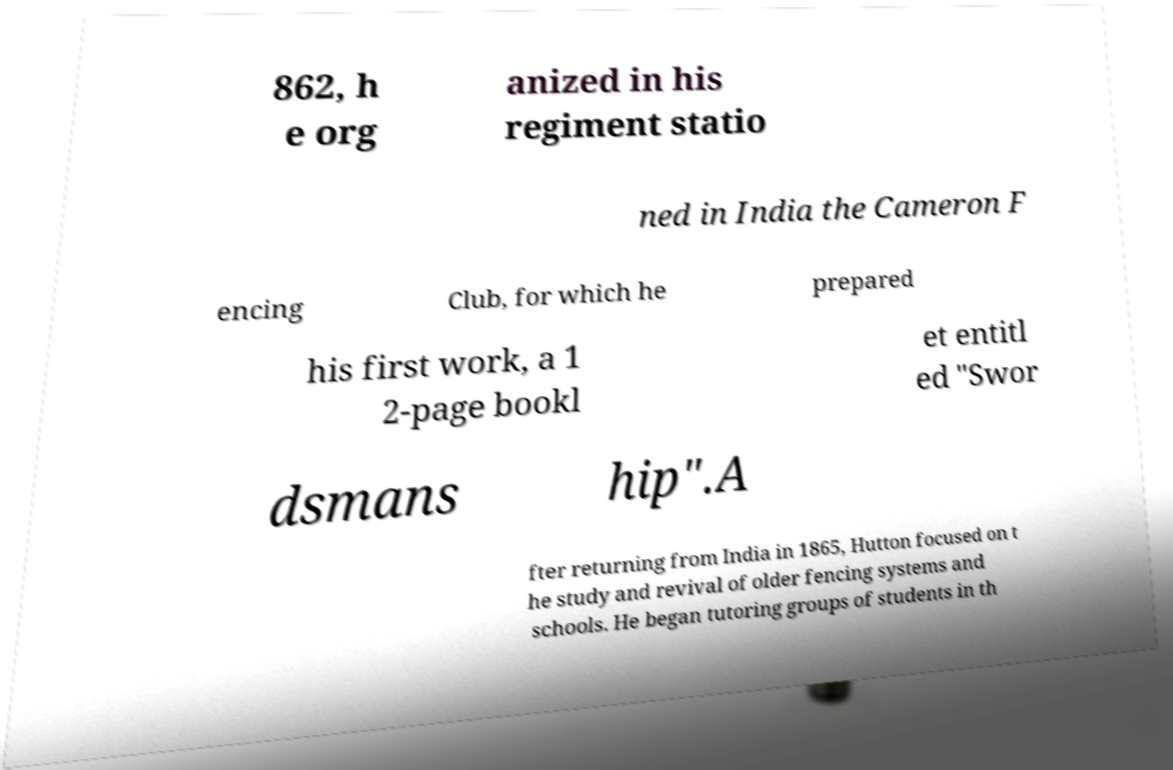Can you read and provide the text displayed in the image?This photo seems to have some interesting text. Can you extract and type it out for me? 862, h e org anized in his regiment statio ned in India the Cameron F encing Club, for which he prepared his first work, a 1 2-page bookl et entitl ed "Swor dsmans hip".A fter returning from India in 1865, Hutton focused on t he study and revival of older fencing systems and schools. He began tutoring groups of students in th 